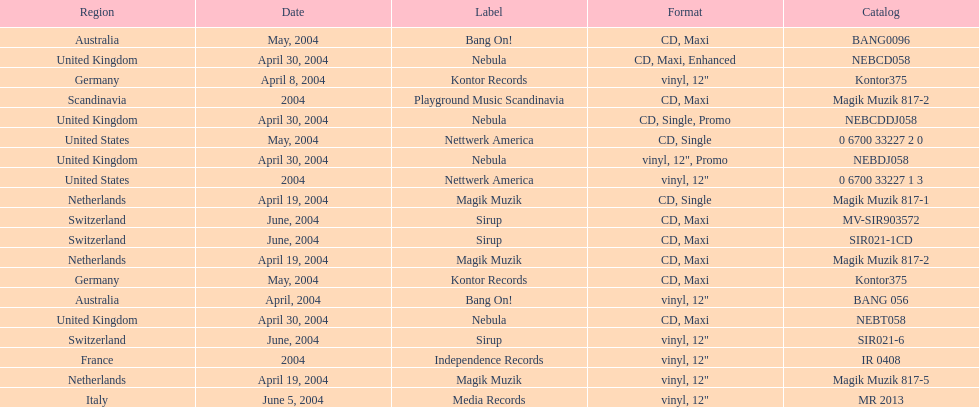What region was on the label sirup? Switzerland. 